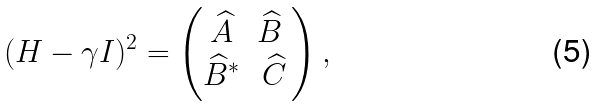Convert formula to latex. <formula><loc_0><loc_0><loc_500><loc_500>( H - \gamma I ) ^ { 2 } = \begin{pmatrix} \widehat { A } & \widehat { B } \ \\ \widehat { B } ^ { * } & \widehat { C } \end{pmatrix} ,</formula> 